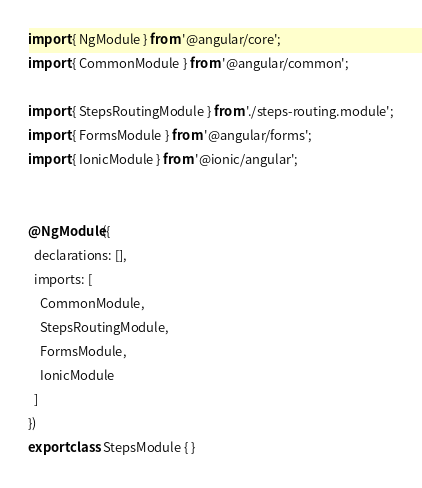Convert code to text. <code><loc_0><loc_0><loc_500><loc_500><_TypeScript_>import { NgModule } from '@angular/core';
import { CommonModule } from '@angular/common';

import { StepsRoutingModule } from './steps-routing.module';
import { FormsModule } from '@angular/forms';
import { IonicModule } from '@ionic/angular';


@NgModule({
  declarations: [],
  imports: [
    CommonModule,
    StepsRoutingModule,
    FormsModule,
    IonicModule
  ]
})
export class StepsModule { }
</code> 